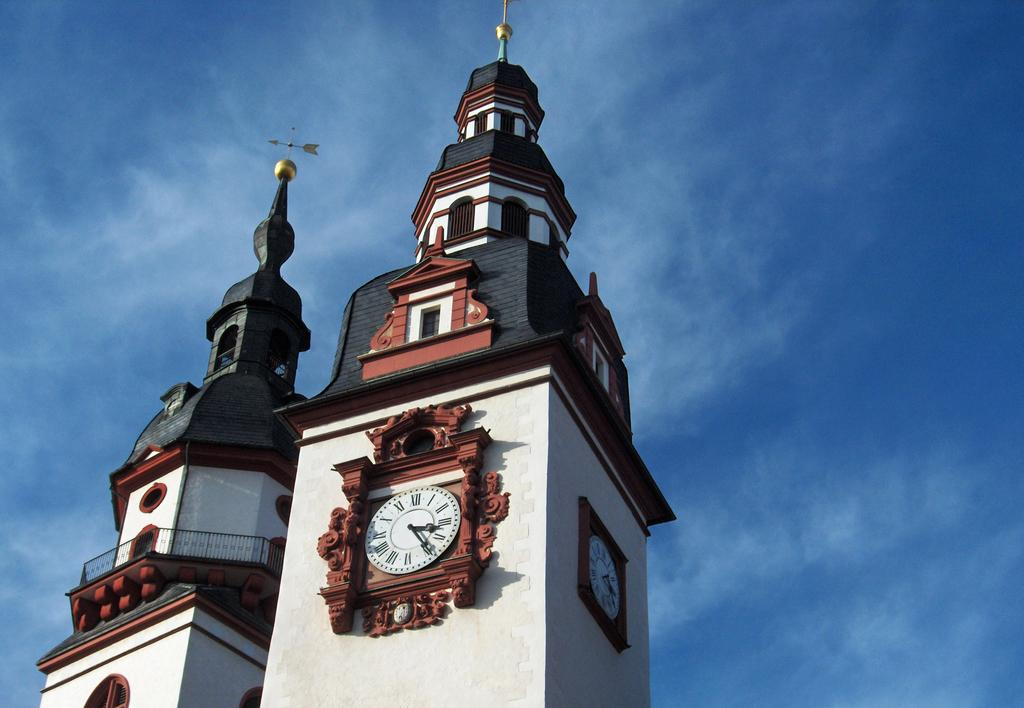What is the main structure in the foreground of the image? There is a building in the foreground of the image. What feature can be seen on the building? There is a clock on the building. What can be seen in the background of the image? The sky is visible in the image. What is the condition of the sky in the image? Clouds are present in the sky. How many farmers are present in the image? There are no farmers present in the image. What type of industry is depicted in the image? There is no industry depicted in the image; it features a building with a clock and a sky with clouds. 